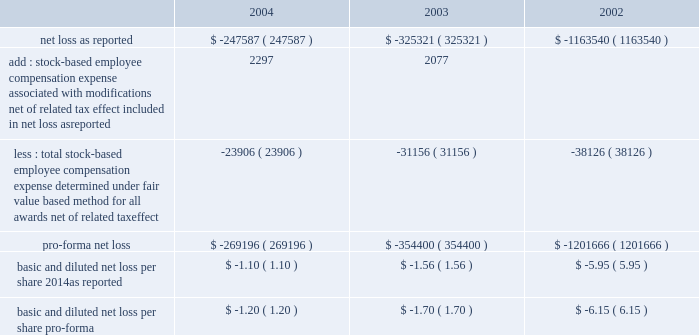American tower corporation and subsidiaries notes to consolidated financial statements 2014 ( continued ) stock-based compensation 2014the company complies with the provisions of sfas no .
148 , 201caccounting for stock-based compensation 2014transition and disclosure 2014an amendment of sfas no .
123 , 201d which provides optional transition guidance for those companies electing to voluntarily adopt the accounting provisions of sfas no .
123 .
The company continues to use accounting principles board opinion no .
25 ( apb no .
25 ) , 201caccounting for stock issued to employees , 201d to account for equity grants and awards to employees , officers and directors and has adopted the disclosure-only provisions of sfas no .
148 .
In accordance with apb no .
25 , the company recognizes compensation expense based on the excess , if any , of the quoted stock price at the grant date of the award or other measurement date over the amount an employee must pay to acquire the stock .
The company 2019s stock option plans are more fully described in note 13 .
In december 2004 , the fasb issued sfas no .
123r , 201cshare-based payment 201d ( sfas no .
123r ) , described below .
The table illustrates the effect on net loss and net loss per share if the company had applied the fair value recognition provisions of sfas no .
123 ( as amended ) to stock-based compensation .
The estimated fair value of each option is calculated using the black-scholes option-pricing model ( in thousands , except per share amounts ) : .
During the year ended december 31 , 2004 and 2003 , the company modified certain option awards to accelerate vesting and recorded charges of $ 3.0 million and $ 2.3 million , respectively , and corresponding increases to additional paid in capital in the accompanying consolidated financial statements .
Fair value of financial instruments 2014the carrying values of the company 2019s financial instruments , with the exception of long-term obligations , including current portion , reasonably approximate the related fair values as of december 31 , 2004 and 2003 .
As of december 31 , 2004 , the carrying amount and fair value of long-term obligations , including current portion , were $ 3.3 billion and $ 3.6 billion , respectively .
As of december 31 , 2003 , the carrying amount and fair value of long-term obligations , including current portion , were $ 3.4 billion and $ 3.6 billion , respectively .
Fair values are based primarily on quoted market prices for those or similar instruments .
Retirement plan 2014the company has a 401 ( k ) plan covering substantially all employees who meet certain age and employment requirements .
Under the plan , the company matching contribution for periods prior to june 30 , 2004 was 35% ( 35 % ) up to a maximum 5% ( 5 % ) of a participant 2019s contributions .
Effective july 1 , 2004 , the plan was amended to increase the company match to 50% ( 50 % ) up to a maximum 6% ( 6 % ) of a participant 2019s contributions .
The company contributed approximately $ 533000 , $ 825000 and $ 979000 to the plan for the years ended december 31 , 2004 , 2003 and 2002 , respectively .
Recent accounting pronouncements 2014in december 2004 , the fasb issued sfas no .
123r , which is a revision of sfas no .
123 , 201caccounting for stock-based compensation , 201d and supersedes apb no .
25 , accounting for .
What is the percentage change in 401 ( k ) contributed amounts from 2002 to 2003? 
Computations: ((825000 - 979000) / 979000)
Answer: -0.1573. 